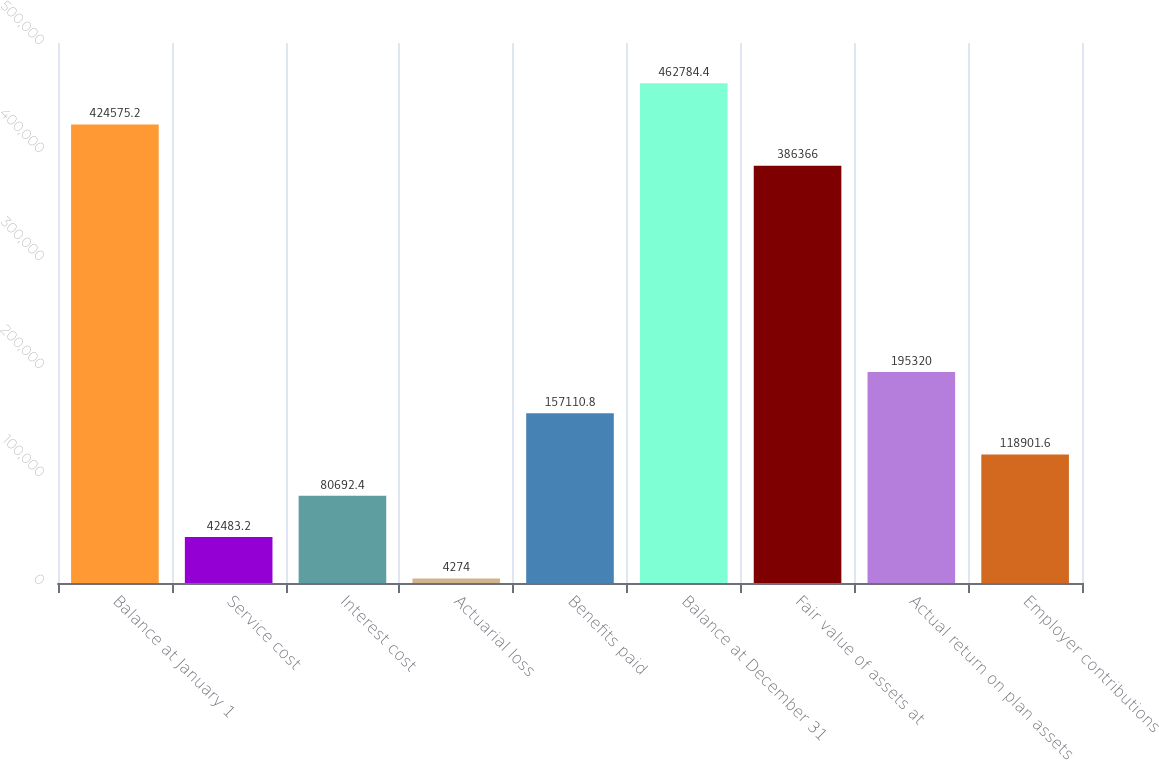Convert chart to OTSL. <chart><loc_0><loc_0><loc_500><loc_500><bar_chart><fcel>Balance at January 1<fcel>Service cost<fcel>Interest cost<fcel>Actuarial loss<fcel>Benefits paid<fcel>Balance at December 31<fcel>Fair value of assets at<fcel>Actual return on plan assets<fcel>Employer contributions<nl><fcel>424575<fcel>42483.2<fcel>80692.4<fcel>4274<fcel>157111<fcel>462784<fcel>386366<fcel>195320<fcel>118902<nl></chart> 